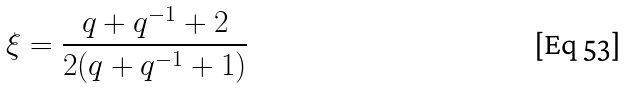Convert formula to latex. <formula><loc_0><loc_0><loc_500><loc_500>\xi = \frac { q + q ^ { - 1 } + 2 } { 2 ( q + q ^ { - 1 } + 1 ) }</formula> 